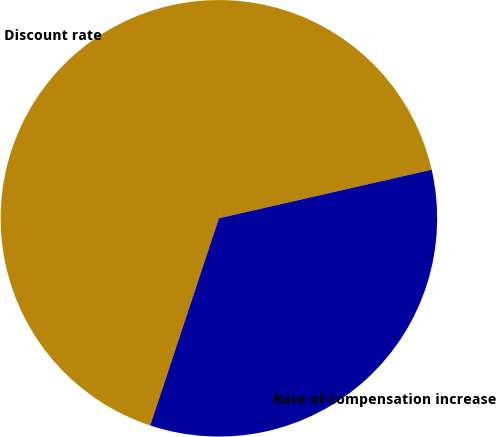Convert chart to OTSL. <chart><loc_0><loc_0><loc_500><loc_500><pie_chart><fcel>Discount rate<fcel>Rate of compensation increase<nl><fcel>66.33%<fcel>33.67%<nl></chart> 